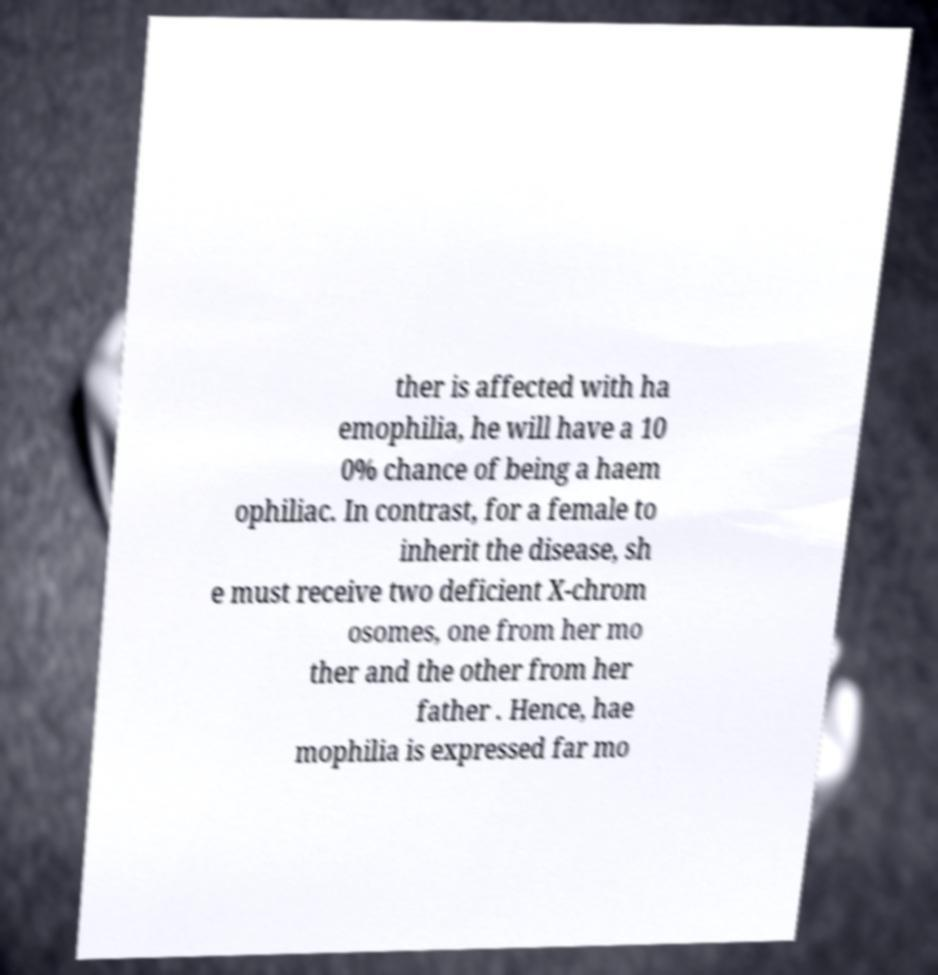Can you accurately transcribe the text from the provided image for me? ther is affected with ha emophilia, he will have a 10 0% chance of being a haem ophiliac. In contrast, for a female to inherit the disease, sh e must receive two deficient X-chrom osomes, one from her mo ther and the other from her father . Hence, hae mophilia is expressed far mo 